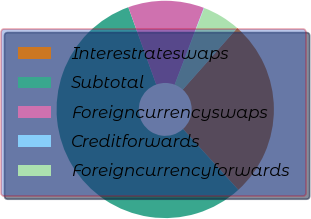Convert chart to OTSL. <chart><loc_0><loc_0><loc_500><loc_500><pie_chart><fcel>Interestrateswaps<fcel>Subtotal<fcel>Foreigncurrencyswaps<fcel>Creditforwards<fcel>Foreigncurrencyforwards<nl><fcel>26.74%<fcel>56.22%<fcel>11.3%<fcel>0.06%<fcel>5.68%<nl></chart> 